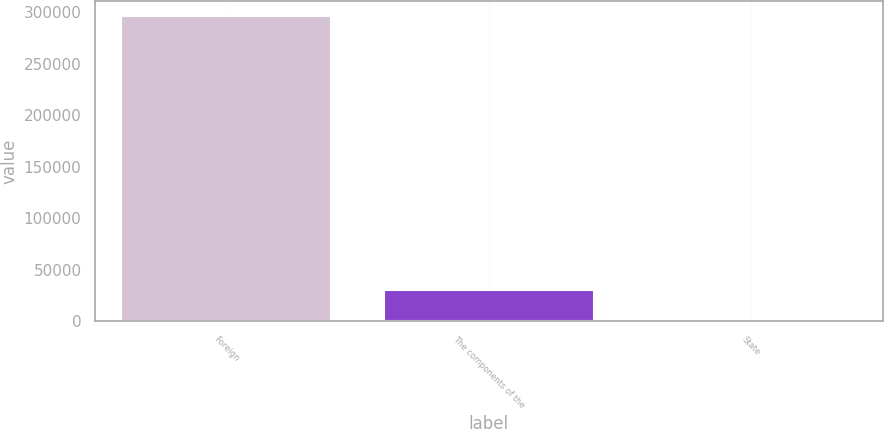Convert chart. <chart><loc_0><loc_0><loc_500><loc_500><bar_chart><fcel>Foreign<fcel>The components of the<fcel>State<nl><fcel>296311<fcel>30193.6<fcel>625<nl></chart> 